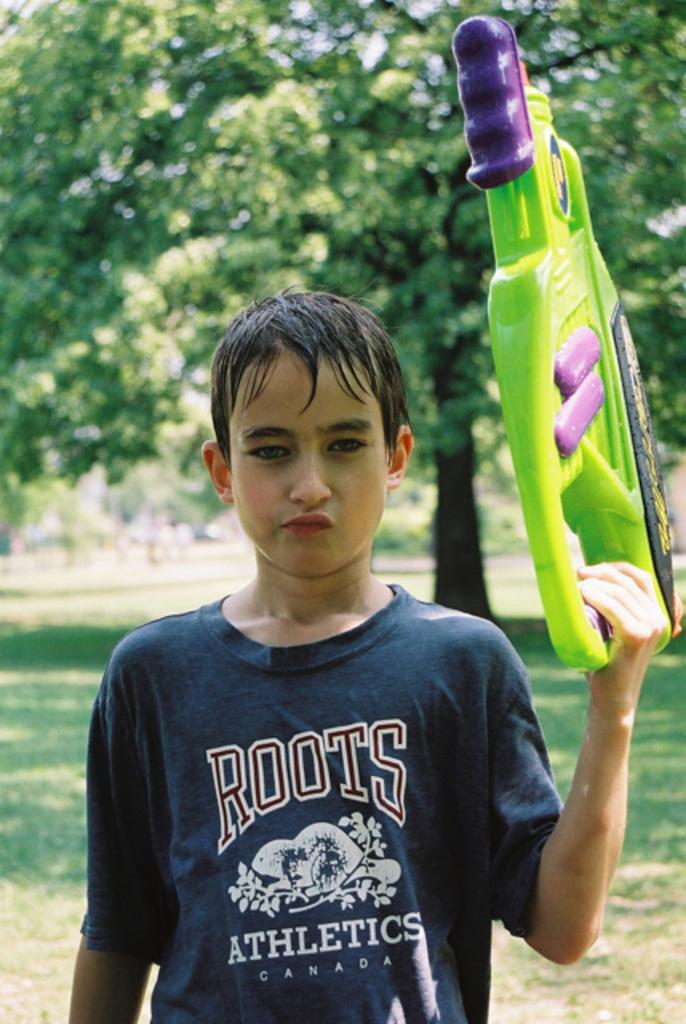Who is the main subject in the image? There is a boy in the center of the image. What is the boy holding in the image? The boy is holding a toy gun. What can be seen in the background of the image? There are trees in the background of the image. Where is the faucet located in the image? There is no faucet present in the image. How many houses can be seen in the image? There are no houses visible in the image. 